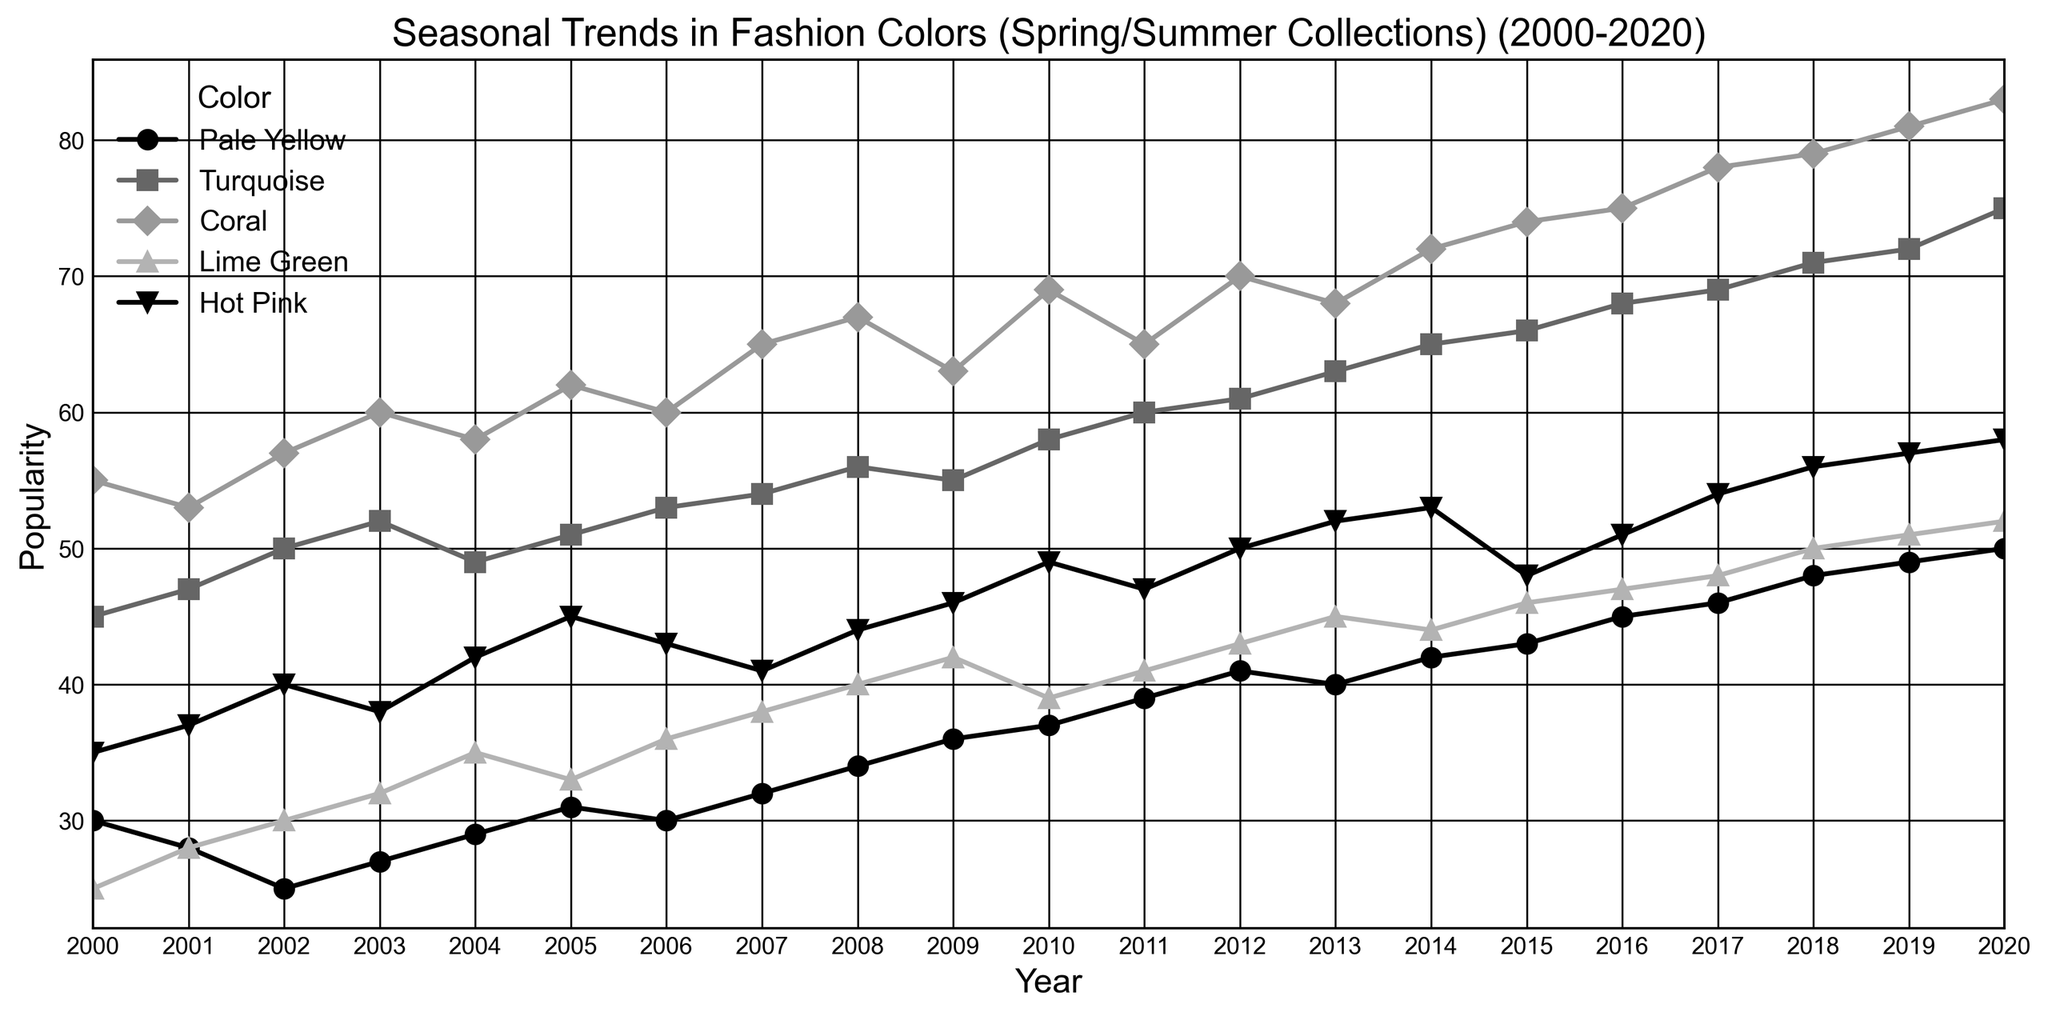Q: Which color had the highest popularity in the year 2015? To find the highest popularity for 2015, observe the data points for all colors for this year. Coral shows a value of 74, which is the highest among all colors.
Answer: Coral Q: What is the average popularity of Hot Pink over the entire period? Sum the popularity values for Hot Pink across all years and then divide by the number of years (21). Calculation: (35+37+40+38+42+45+43+41+44+46+49+47+50+52+53+48+51+54+56+57+58)/21 = 910/21 = 43.33
Answer: 43.33 Q: Did Turquoise's popularity show an overall increasing or decreasing trend from 2000 to 2020? By examining the data on the plot for Turquoise from 2000 to 2020, observe the trendline. It starts at 45 in 2000 and ends at 75 in 2020, showing an overall increasing trend.
Answer: Increasing Q: Which year did Lime Green see the biggest increase in popularity compared to the previous year? Look at the changes in popularity for each year and calculate the differences. The biggest jump is from 2010 (39) to 2011 (41), a difference of 2.
Answer: 2012 Q: Between Coral and Turquoise, which color had a greater increase in popularity from 2000 to 2020? Compare the differences between the 2020 and 2000 values for both colors: Coral (83-55=28) and Turquoise (75-45=30). Turquoise has a greater increase (30 vs. 28).
Answer: Turquoise Q: In which year was the popularity of Pale Yellow equal to that of Turquoise? Find the year when both Pale Yellow and Turquoise have the same popularity value. In 2006, both have a popularity of 30 (2007).
Answer: 2007 Q: What's the median popularity value for Coral over the years 2000 to 2020? Arrange the popularity values for Coral in order and find the middle value. The 21 values are sorted, and the median is the 11th value: (55+53+57+60+58+62+60+65+67+63+69+65+70+68+72+74+75+78+79+81+83)/21. The median is 65.
Answer: 65 Q: By how much did Hot Pink's popularity increase from 2000 to 2020? Subtract the popularity value of Hot Pink in 2000 (35) from its value in 2020 (58). The increase is 58 - 35 = 23.
Answer: 23 Q: How many colors had a popularity greater than 70 in the year 2018? Identify the colors that had a popularity over 70 in 2018: Turquoise (71), Coral (79). Two colors fit this criterion.
Answer: 2 